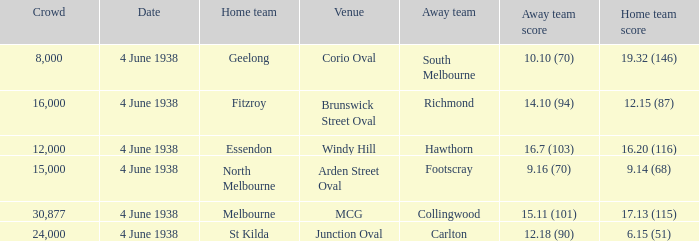Could you help me parse every detail presented in this table? {'header': ['Crowd', 'Date', 'Home team', 'Venue', 'Away team', 'Away team score', 'Home team score'], 'rows': [['8,000', '4 June 1938', 'Geelong', 'Corio Oval', 'South Melbourne', '10.10 (70)', '19.32 (146)'], ['16,000', '4 June 1938', 'Fitzroy', 'Brunswick Street Oval', 'Richmond', '14.10 (94)', '12.15 (87)'], ['12,000', '4 June 1938', 'Essendon', 'Windy Hill', 'Hawthorn', '16.7 (103)', '16.20 (116)'], ['15,000', '4 June 1938', 'North Melbourne', 'Arden Street Oval', 'Footscray', '9.16 (70)', '9.14 (68)'], ['30,877', '4 June 1938', 'Melbourne', 'MCG', 'Collingwood', '15.11 (101)', '17.13 (115)'], ['24,000', '4 June 1938', 'St Kilda', 'Junction Oval', 'Carlton', '12.18 (90)', '6.15 (51)']]} What was the score for Geelong? 10.10 (70). 